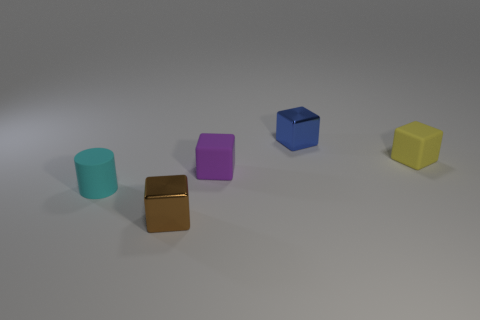Do the small object that is to the right of the blue metallic cube and the tiny purple object have the same material?
Provide a succinct answer. Yes. Are there fewer tiny yellow matte cubes than big purple metal things?
Ensure brevity in your answer.  No. There is a metallic object to the left of the metallic object that is behind the small brown thing; is there a tiny yellow rubber object on the left side of it?
Offer a very short reply. No. Is the shape of the thing that is behind the yellow matte thing the same as  the yellow thing?
Offer a terse response. Yes. Is the number of small brown things behind the tiny brown block greater than the number of metallic blocks?
Offer a very short reply. No. There is a shiny block that is behind the tiny brown thing; is it the same color as the rubber cylinder?
Offer a terse response. No. Are there any other things of the same color as the cylinder?
Provide a succinct answer. No. There is a block on the right side of the small shiny thing behind the rubber cube in front of the yellow rubber cube; what is its color?
Your answer should be very brief. Yellow. Is the size of the purple object the same as the yellow matte object?
Offer a terse response. Yes. What number of yellow rubber blocks have the same size as the purple object?
Your answer should be very brief. 1. 